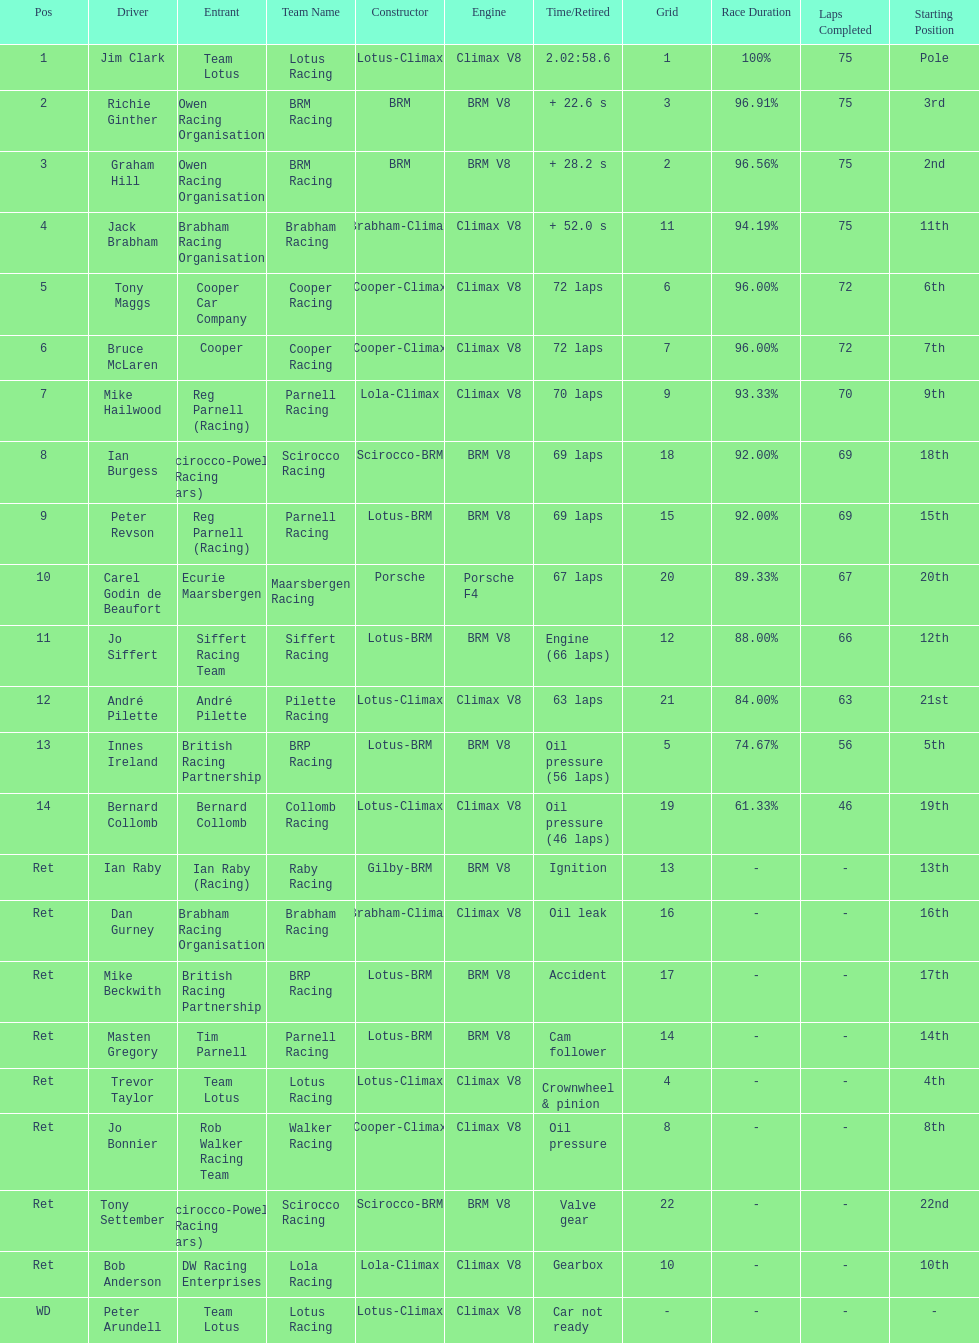What is the number of americans in the top 5? 1. 